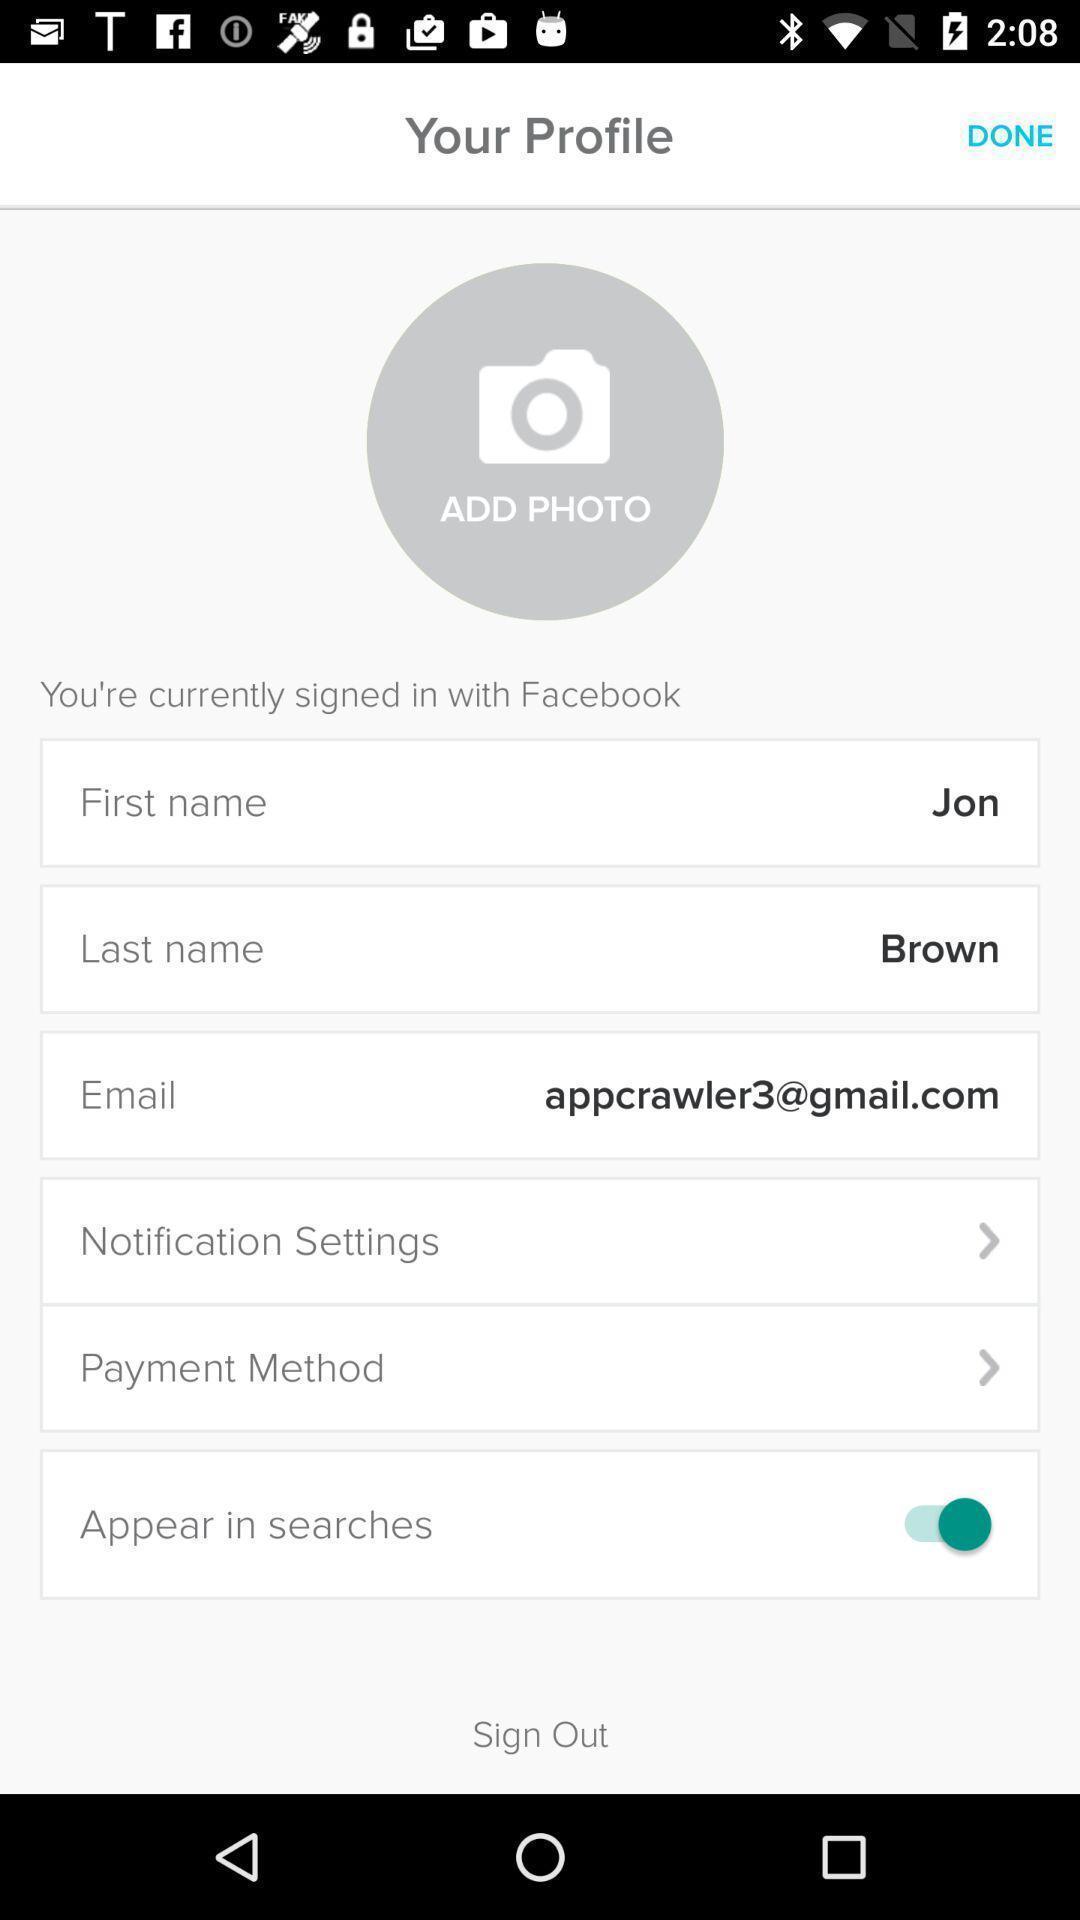Describe this image in words. Screen shows profile details. 